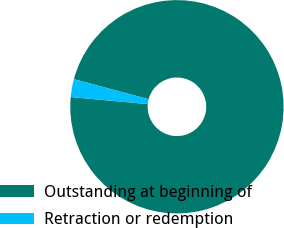Convert chart. <chart><loc_0><loc_0><loc_500><loc_500><pie_chart><fcel>Outstanding at beginning of<fcel>Retraction or redemption<nl><fcel>97.29%<fcel>2.71%<nl></chart> 